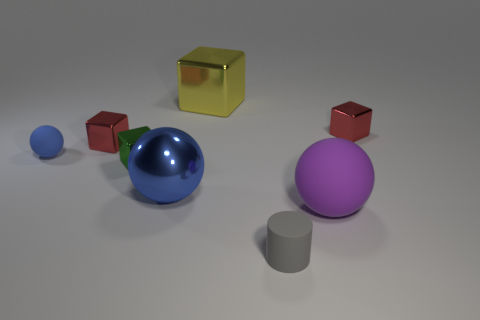Subtract all red cubes. How many were subtracted if there are1red cubes left? 1 Add 2 tiny cyan cubes. How many objects exist? 10 Subtract all balls. How many objects are left? 5 Add 7 green shiny things. How many green shiny things are left? 8 Add 6 gray rubber balls. How many gray rubber balls exist? 6 Subtract 0 gray cubes. How many objects are left? 8 Subtract all tiny metal cylinders. Subtract all red objects. How many objects are left? 6 